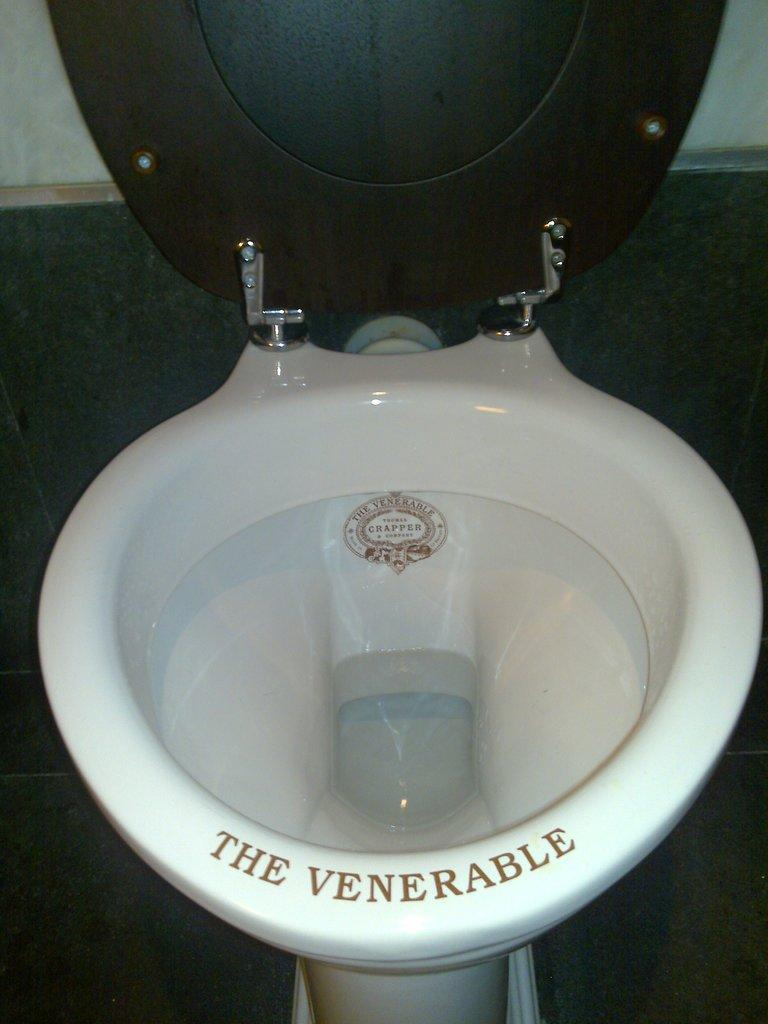Provide a one-sentence caption for the provided image. A white toilet bears the name "The Venerable.". 